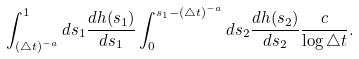<formula> <loc_0><loc_0><loc_500><loc_500>\int _ { ( \triangle t ) ^ { - a } } ^ { 1 } d s _ { 1 } \frac { d h ( s _ { 1 } ) } { d s _ { 1 } } \int _ { 0 } ^ { s _ { 1 } - ( \triangle t ) ^ { - a } } d s _ { 2 } \frac { d h ( s _ { 2 } ) } { d s _ { 2 } } \frac { c } { \log \triangle t } .</formula> 